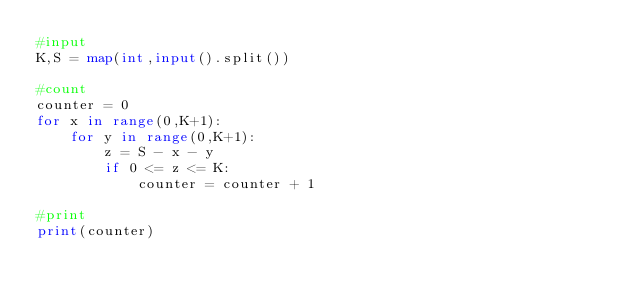<code> <loc_0><loc_0><loc_500><loc_500><_Python_>#input
K,S = map(int,input().split()) 

#count
counter = 0
for x in range(0,K+1):
    for y in range(0,K+1):
        z = S - x - y
        if 0 <= z <= K:
            counter = counter + 1

#print
print(counter)</code> 